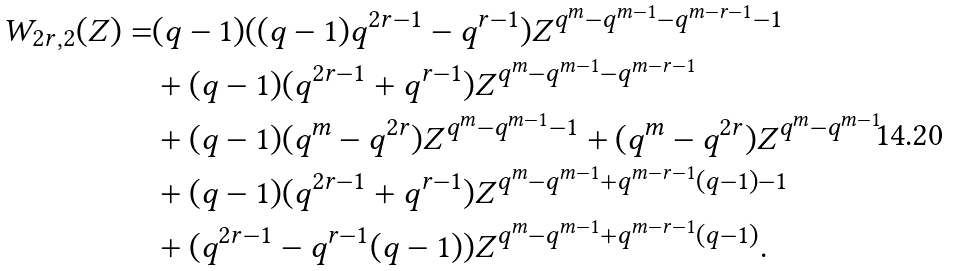Convert formula to latex. <formula><loc_0><loc_0><loc_500><loc_500>W _ { 2 r , 2 } ( Z ) = & ( q - 1 ) ( ( q - 1 ) q ^ { 2 r - 1 } - q ^ { r - 1 } ) Z ^ { q ^ { m } - q ^ { m - 1 } - q ^ { m - r - 1 } - 1 } \\ & + ( q - 1 ) ( q ^ { 2 r - 1 } + q ^ { r - 1 } ) Z ^ { q ^ { m } - q ^ { m - 1 } - q ^ { m - r - 1 } } \\ & + ( q - 1 ) ( q ^ { m } - q ^ { 2 r } ) Z ^ { q ^ { m } - q ^ { m - 1 } - 1 } + ( q ^ { m } - q ^ { 2 r } ) Z ^ { q ^ { m } - q ^ { m - 1 } } \\ & + ( q - 1 ) ( q ^ { 2 r - 1 } + q ^ { r - 1 } ) Z ^ { q ^ { m } - q ^ { m - 1 } + q ^ { m - r - 1 } ( q - 1 ) - 1 } \\ & + ( q ^ { 2 r - 1 } - q ^ { r - 1 } ( q - 1 ) ) Z ^ { q ^ { m } - q ^ { m - 1 } + q ^ { m - r - 1 } ( q - 1 ) } .</formula> 